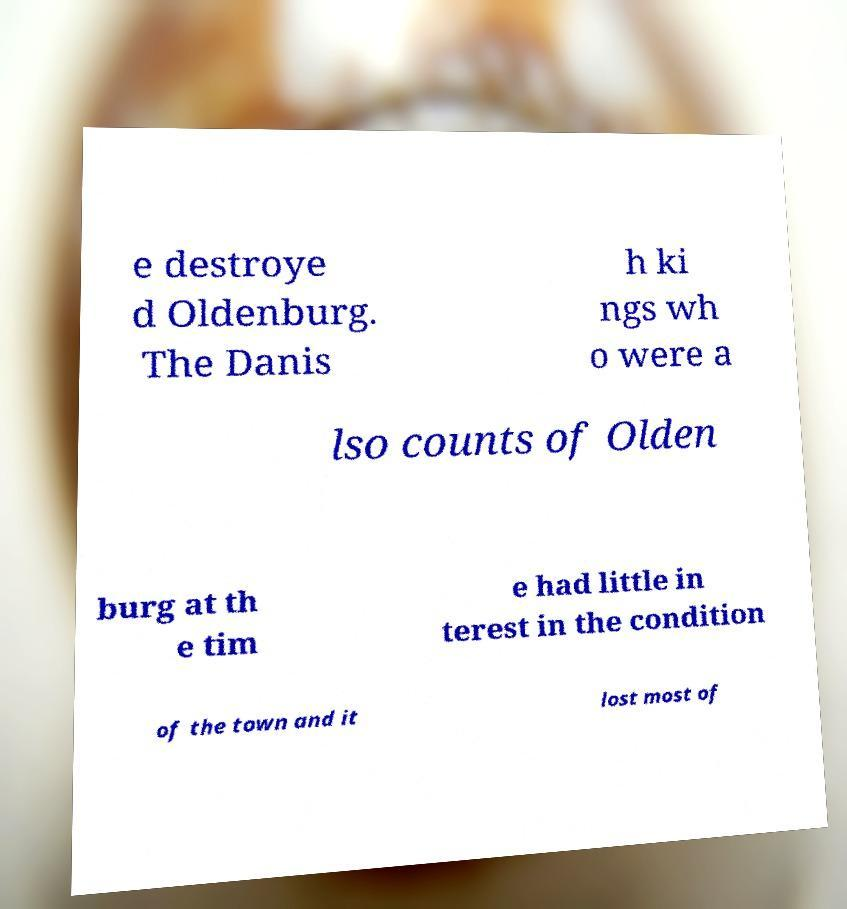There's text embedded in this image that I need extracted. Can you transcribe it verbatim? e destroye d Oldenburg. The Danis h ki ngs wh o were a lso counts of Olden burg at th e tim e had little in terest in the condition of the town and it lost most of 